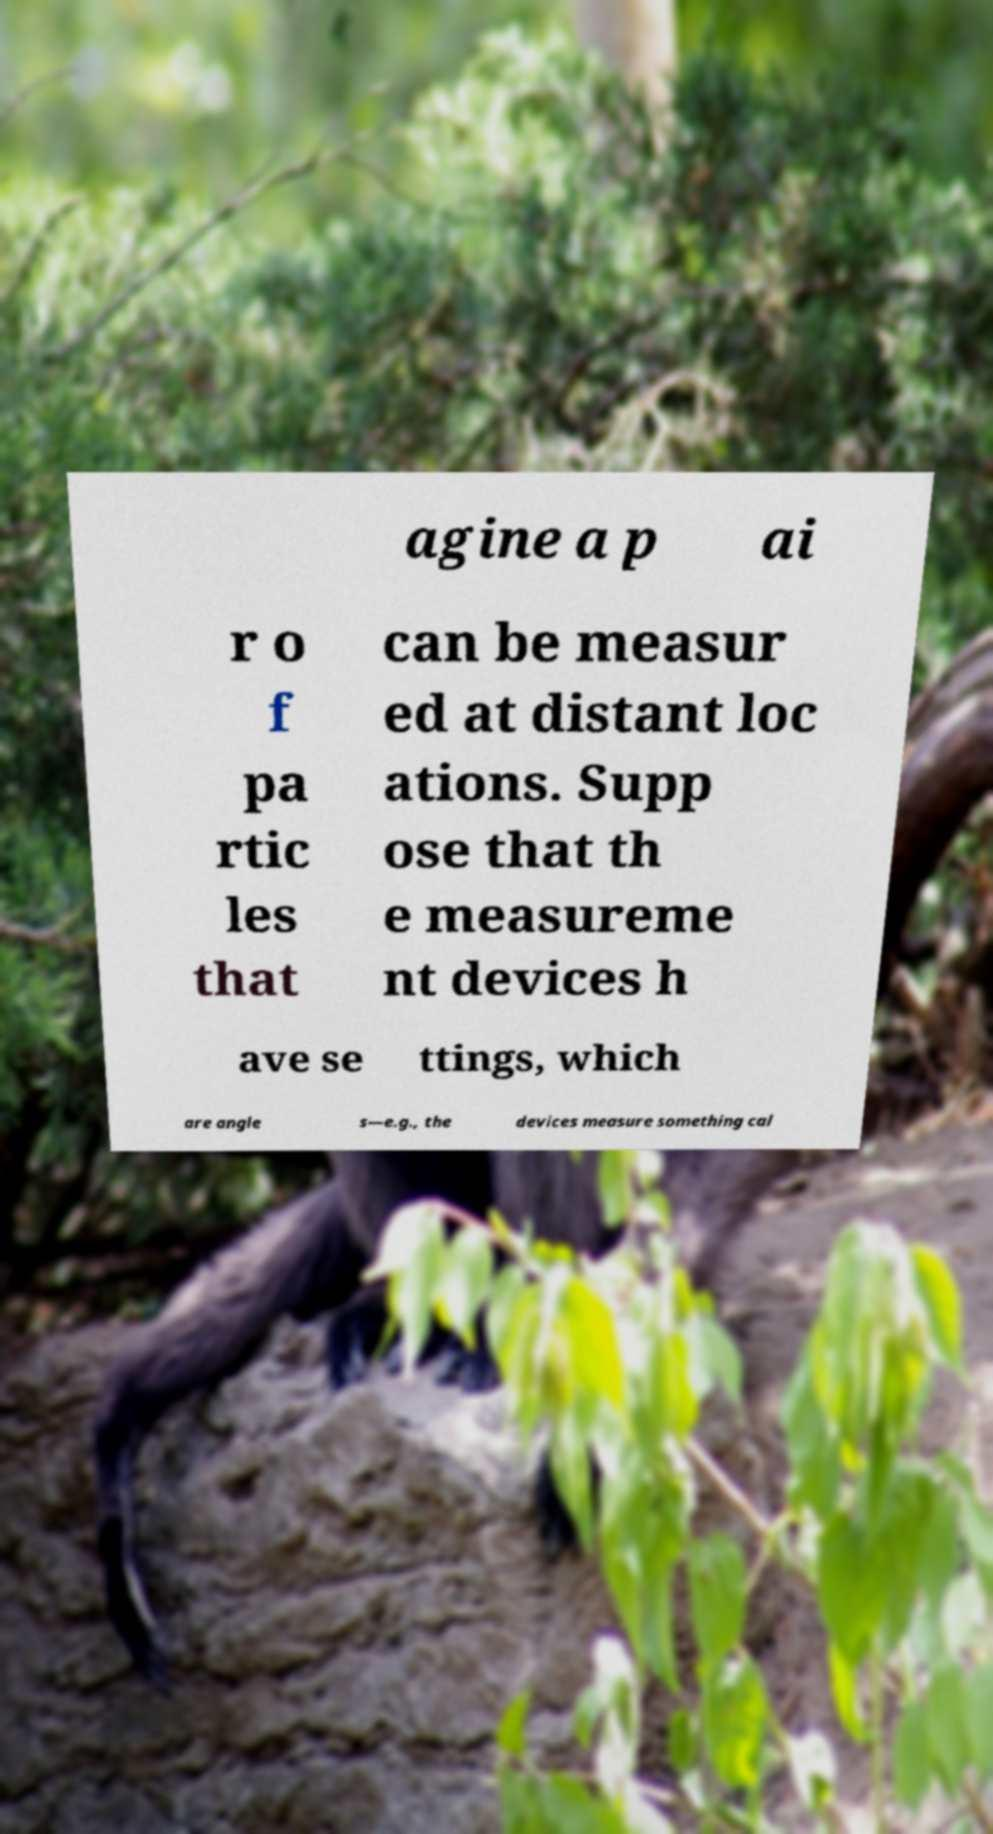Please identify and transcribe the text found in this image. agine a p ai r o f pa rtic les that can be measur ed at distant loc ations. Supp ose that th e measureme nt devices h ave se ttings, which are angle s—e.g., the devices measure something cal 